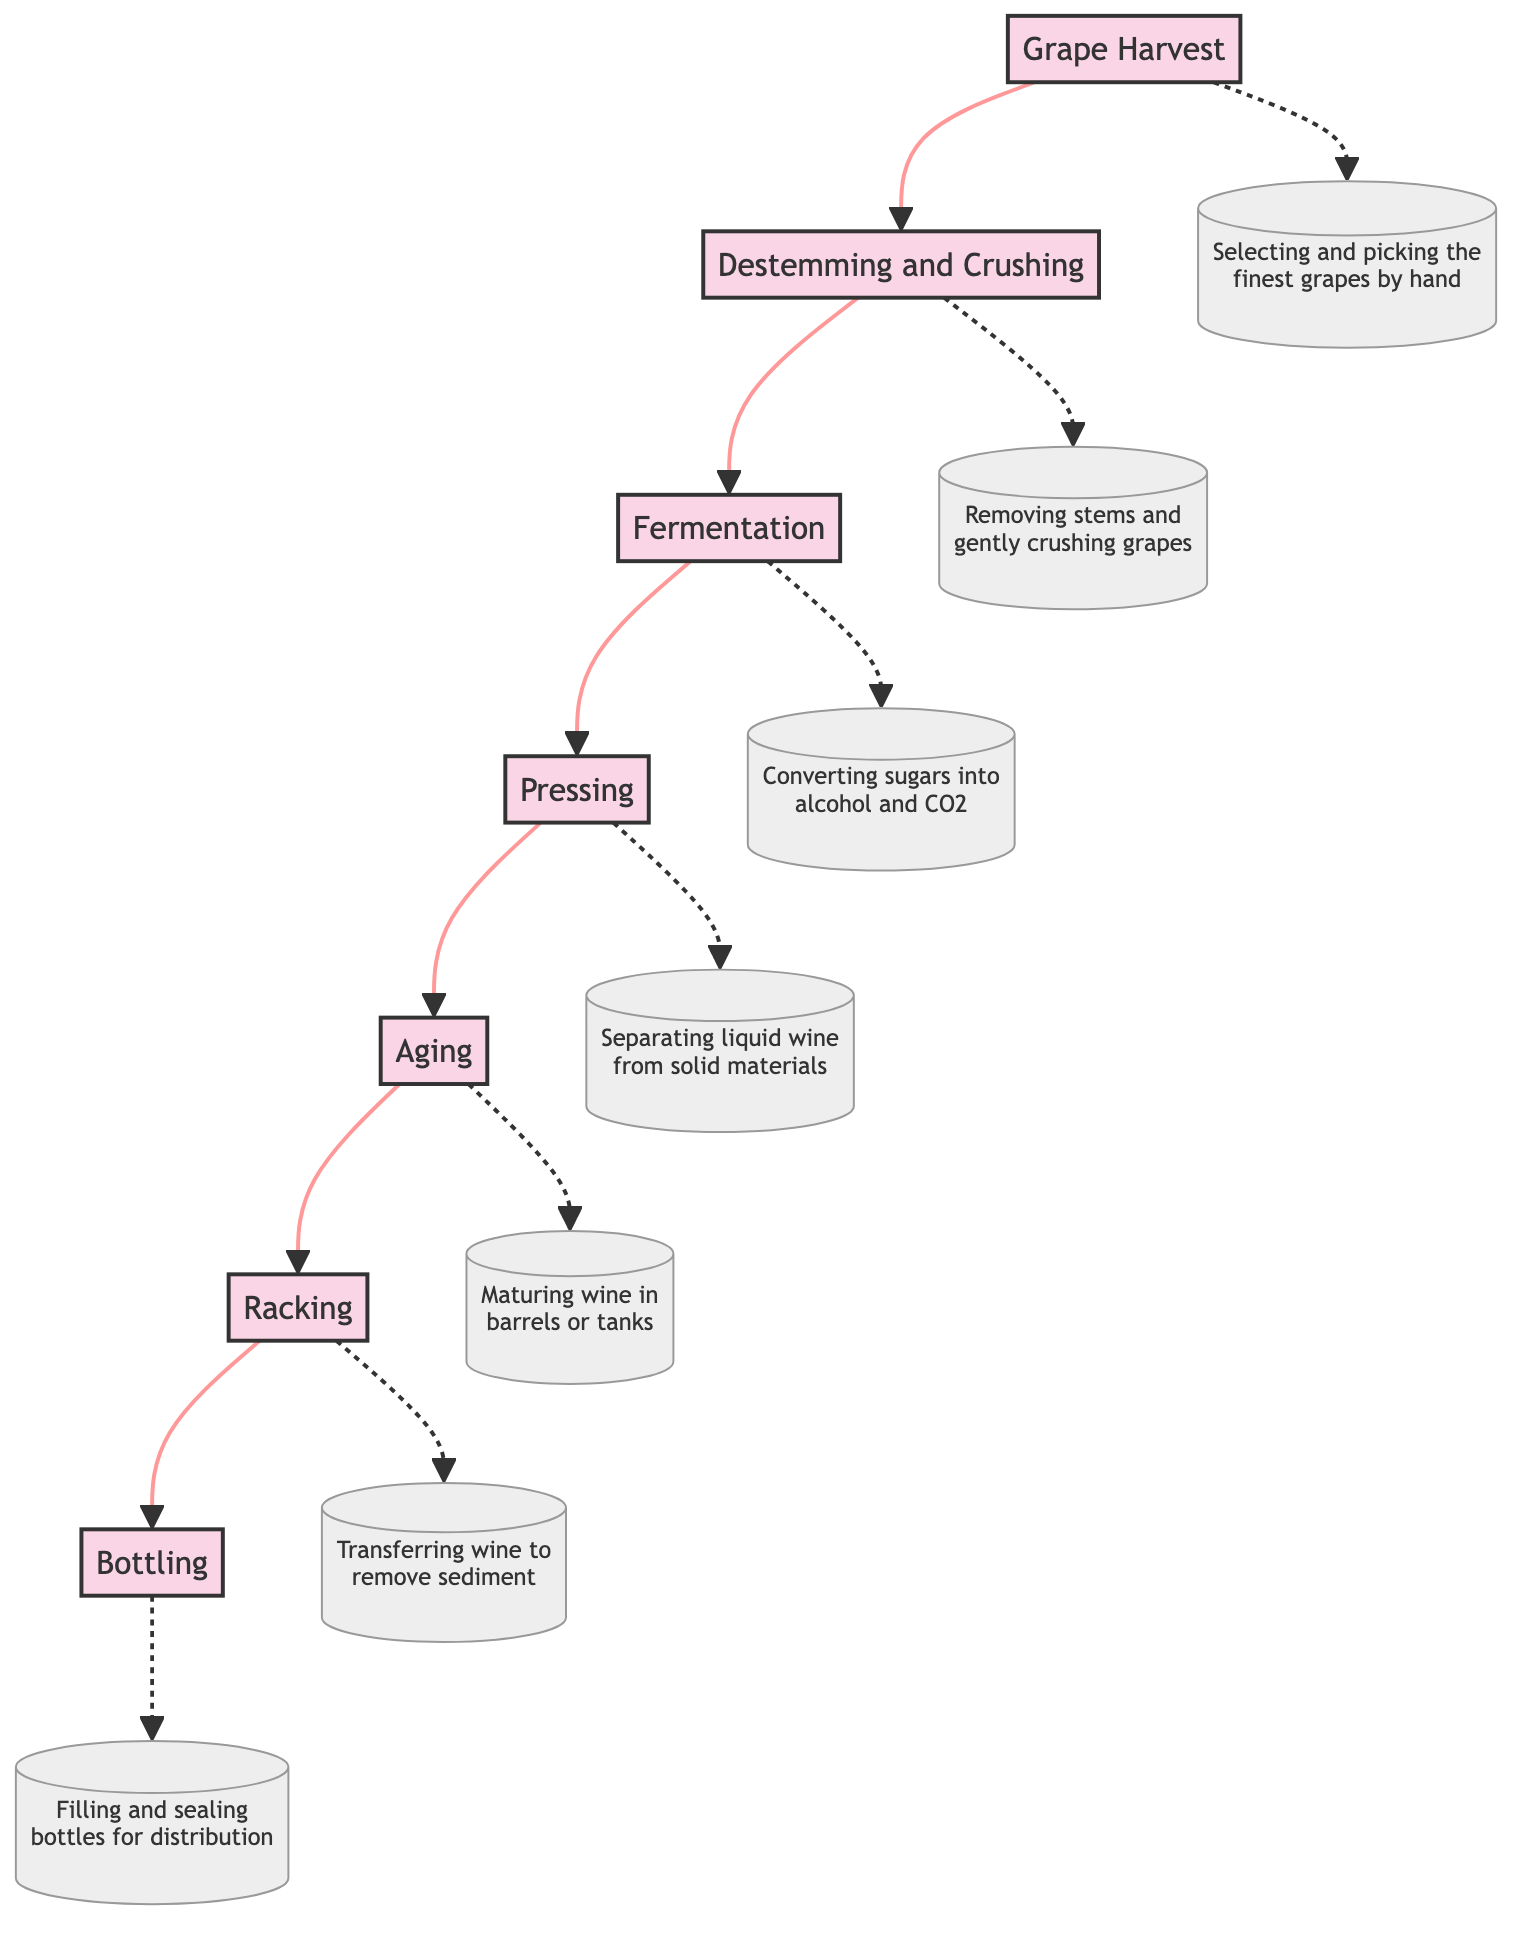What is the first step in the wine aging process? The first step, as shown at the bottom of the diagram, is "Grape Harvest." This node is at the starting point of the flow, indicating it is the initial stage in the wine aging process.
Answer: Grape Harvest How many total steps are depicted in the diagram? The diagram lists seven distinct steps in the wine aging process: Grape Harvest, Destemming and Crushing, Fermentation, Pressing, Aging, Racking, and Bottling. Thus, the total number of nodes is seven.
Answer: 7 What comes immediately after fermentation? The flowchart indicates that after the "Fermentation" step, the next stage is "Pressing." This can be observed by following the arrows in the diagram from C (Fermentation) to D (Pressing).
Answer: Pressing Which stage involves maturing the wine? The node labeled "Aging" specifically describes the process of maturing the wine in barrels or tanks. It is located towards the upper part of the chart, after Pressing and before Racking.
Answer: Aging What is the purpose of racking in the wine process? Based on the description associated with the "Racking" node, its purpose is to clarify the wine and remove sediment. This function is crucial for ensuring the quality of the final product before bottling.
Answer: To clarify the wine and remove sediment What is the final step in the diagram? The last step in the flowchart, as shown at the top, is "Bottling." This is where the finished wine is filled into bottles and sealed, marking the completion of the wine aging process.
Answer: Bottling What happens during the pressing process? The "Pressing" node describes the action of separating the liquid wine from the grape skins and other solid materials after fermentation, indicating its significance in the winemaking process.
Answer: Separating liquid wine from solid materials What is the relationship between fermentation and pressing? The relationship is sequential; "Fermentation" must occur before "Pressing," as illustrated by the direct flow line connecting the two nodes in the diagram. This indicates that pressing cannot happen until fermentation is complete.
Answer: Sequential relationship Which step directly precedes bottling? The diagram clearly shows that "Racking" comes directly before "Bottling," as indicated by the flow connecting these two nodes. Therefore, racking is the last stage before the wine is bottled.
Answer: Racking 